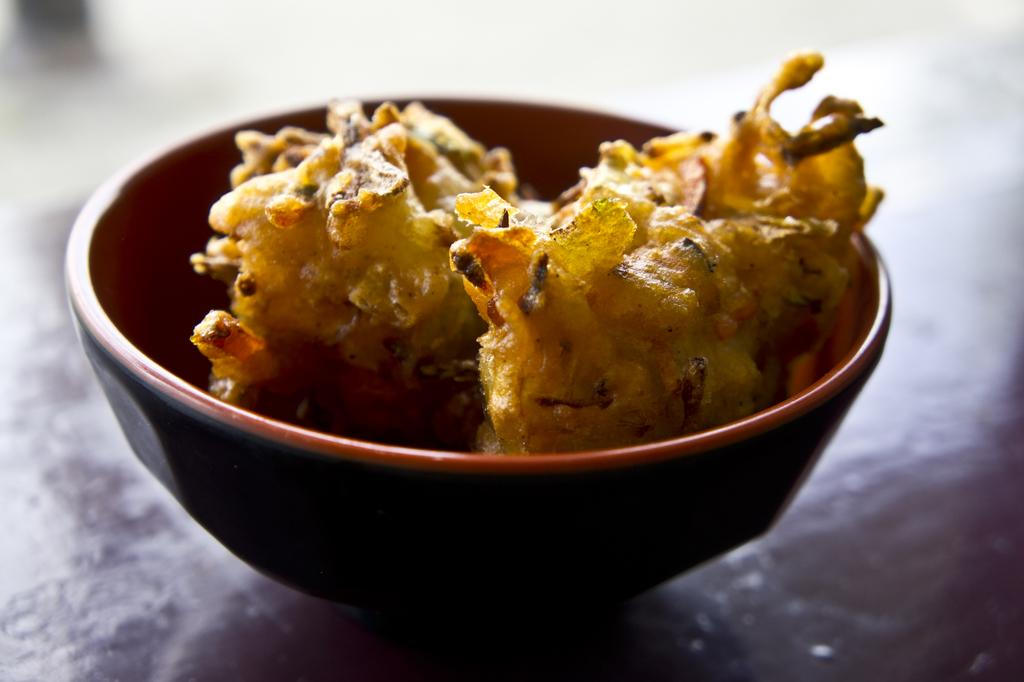What is the main subject of the image? There is a food item in the image. How is the food item contained in the image? The food item is in a bowl. Where is the bowl located in the image? The bowl is in the middle of the image. On what surface is the bowl placed? The bowl is placed on a surface. What type of veil can be seen covering the food item in the image? There is no veil present in the image, and the food item is not covered. 